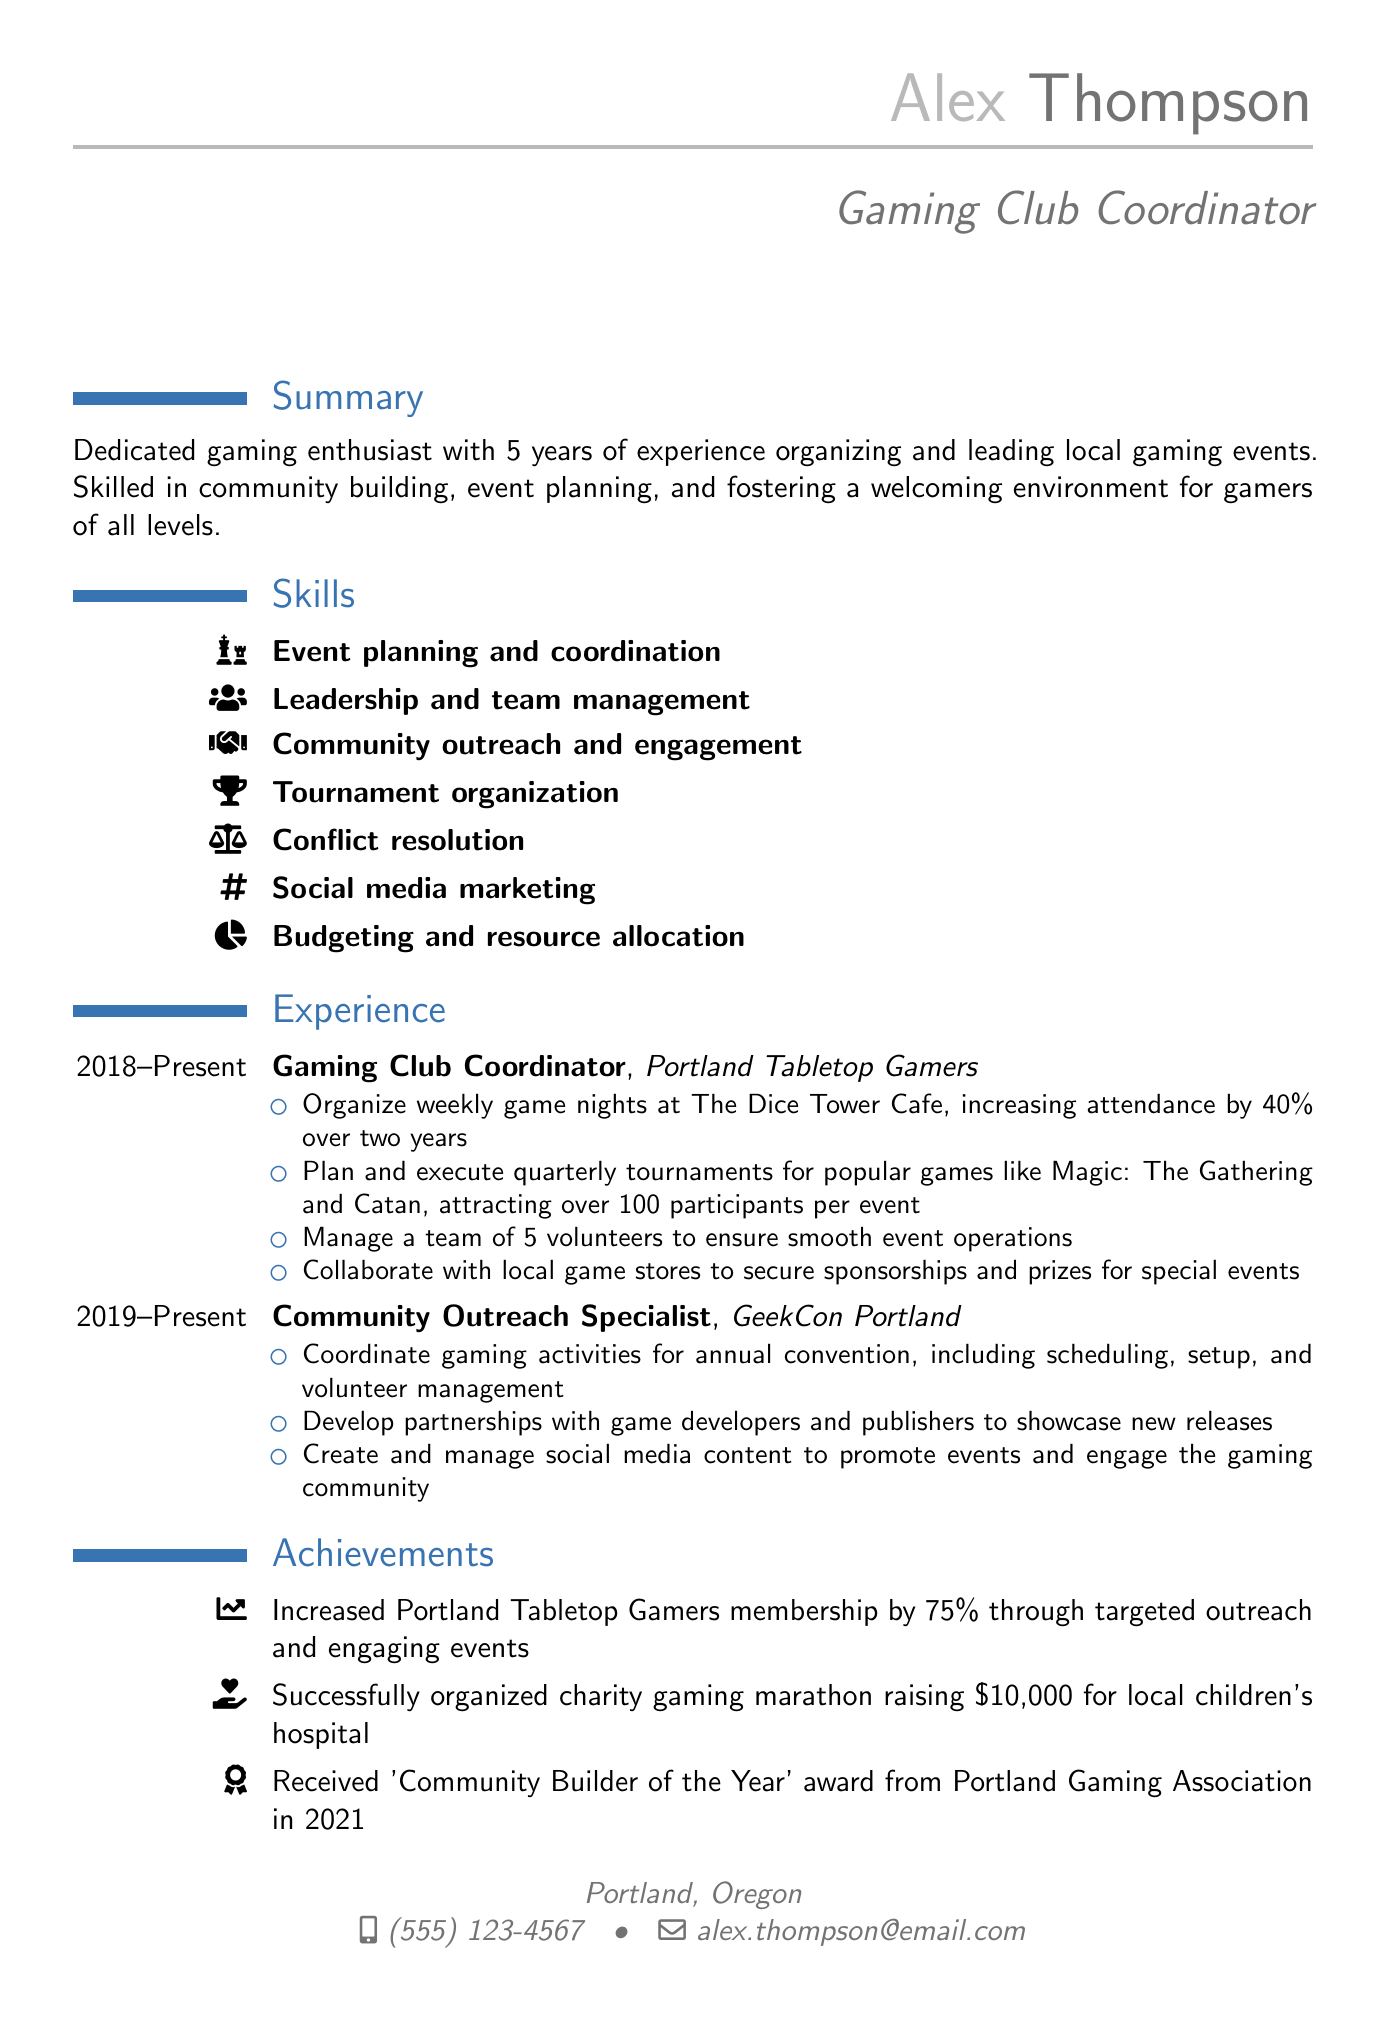What is the title of the document? The title of the document is the position held by the individual, which is mentioned at the beginning.
Answer: Gaming Club Coordinator How many years of experience does Alex have? The years of experience are stated in the summary section of the document.
Answer: 5 years What is the duration of Alex's role as Gaming Club Coordinator? The duration is clearly specified in the experience section under the role of Gaming Club Coordinator.
Answer: 2018 - Present What award did Alex receive in 2021? The achievements section lists specific recognitions, including the year they were received.
Answer: Community Builder of the Year How much money was raised during the charity gaming marathon? The amount raised is specified in the achievements section of the document.
Answer: $10,000 What college did Alex attend? The education section includes the name of the institution where Alex received their degree.
Answer: Portland State University How many participants are typically attracted to the quarterly tournaments? This number is officially stated in the responsibilities of the Gaming Club Coordinator role.
Answer: Over 100 participants What skill involves managing conflict? The skills section identifies various abilities, one of which relates specifically to handling disputes.
Answer: Conflict resolution 